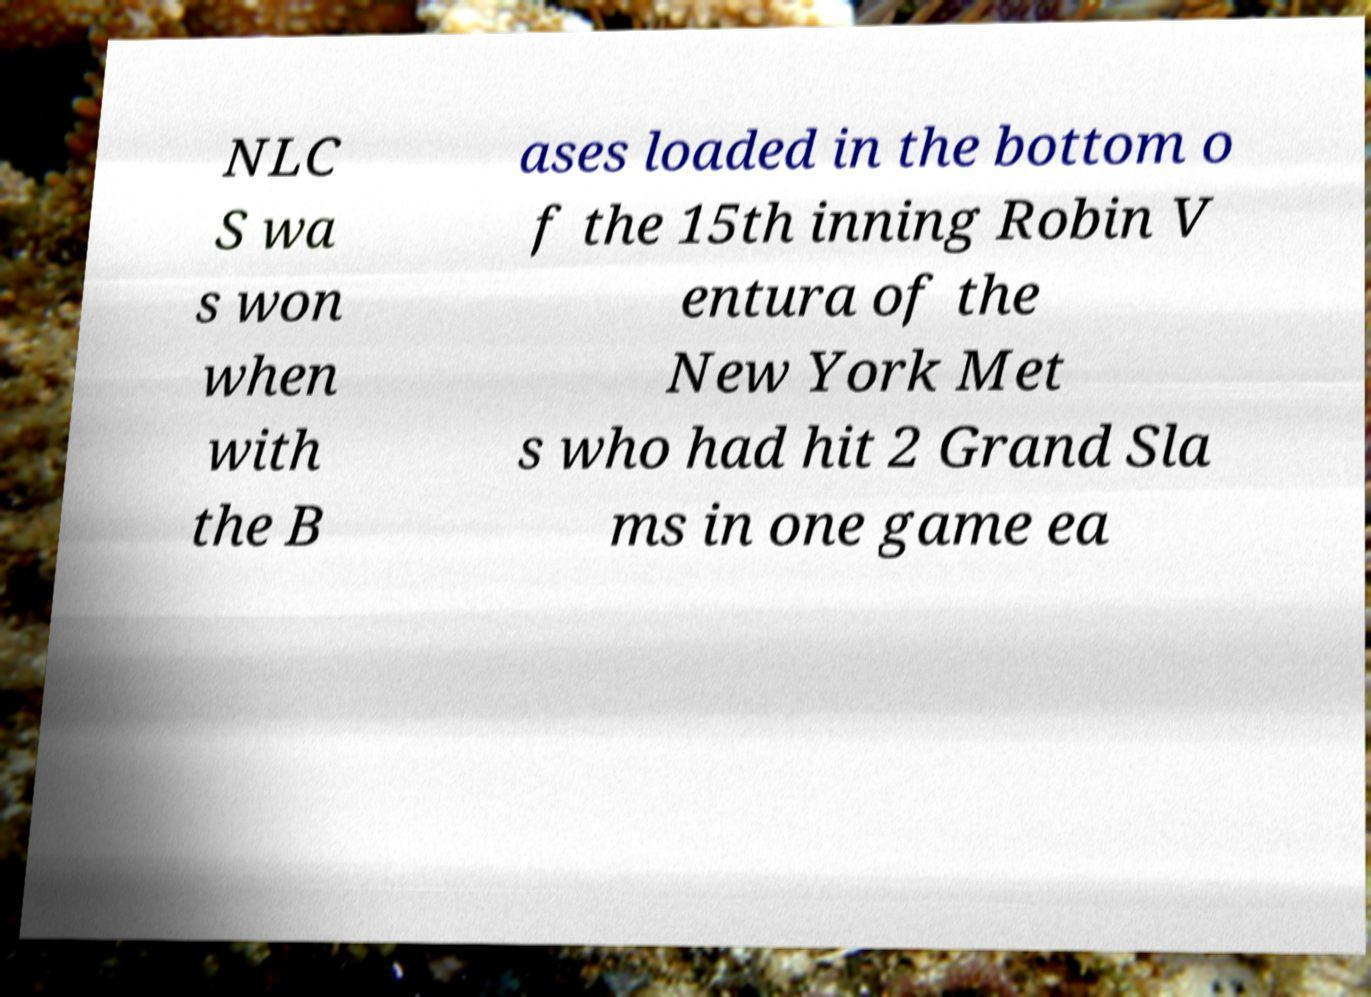Can you read and provide the text displayed in the image?This photo seems to have some interesting text. Can you extract and type it out for me? NLC S wa s won when with the B ases loaded in the bottom o f the 15th inning Robin V entura of the New York Met s who had hit 2 Grand Sla ms in one game ea 